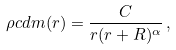<formula> <loc_0><loc_0><loc_500><loc_500>\rho c d m ( r ) = \frac { C } { r ( r + R ) ^ { \alpha } } \, ,</formula> 